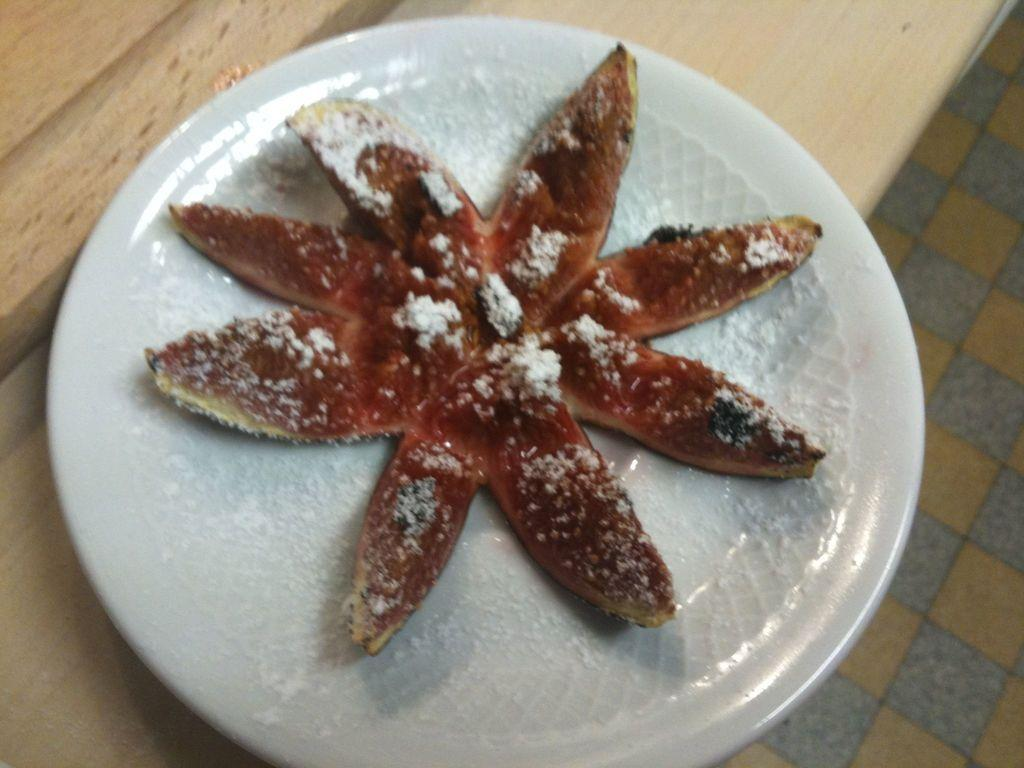What is on the plate that is visible in the image? There is a plate with food in the image. What color is the plate? The plate is white. What color is the food on the plate? The food is red. Where is the plate located in the image? The plate is on a table. What else can be seen in the image besides the plate and food? The floor is visible in the image. What sense is being used to wash the plate in the image? There is no washing of the plate depicted in the image, and senses are not used for washing. 